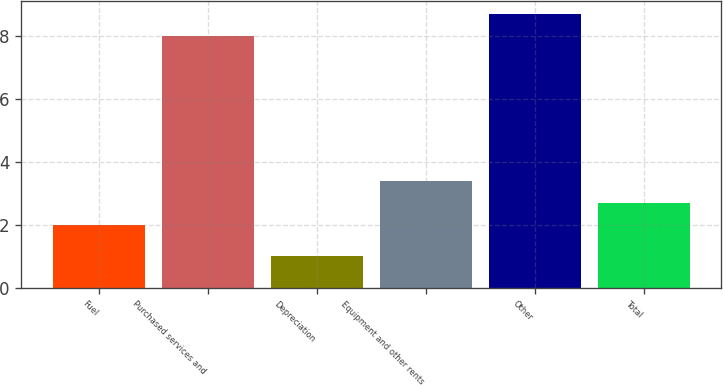Convert chart to OTSL. <chart><loc_0><loc_0><loc_500><loc_500><bar_chart><fcel>Fuel<fcel>Purchased services and<fcel>Depreciation<fcel>Equipment and other rents<fcel>Other<fcel>Total<nl><fcel>2<fcel>8<fcel>1<fcel>3.4<fcel>8.7<fcel>2.7<nl></chart> 